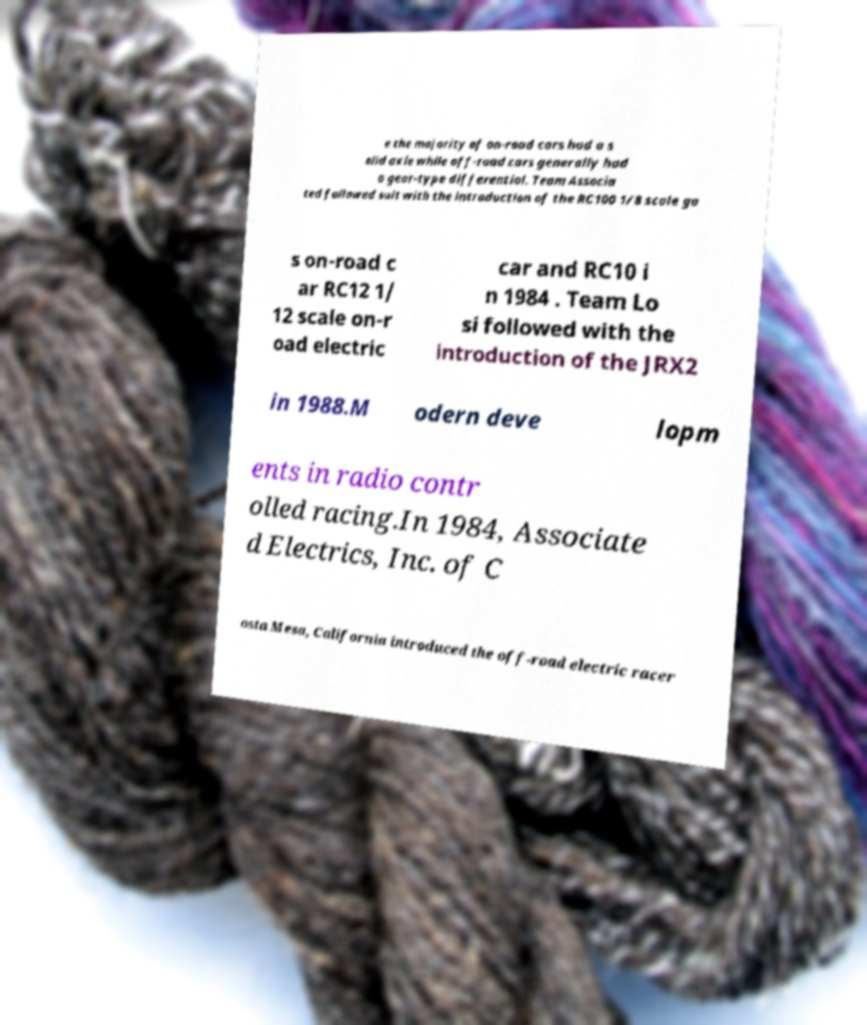For documentation purposes, I need the text within this image transcribed. Could you provide that? e the majority of on-road cars had a s olid axle while off-road cars generally had a gear-type differential. Team Associa ted followed suit with the introduction of the RC100 1/8 scale ga s on-road c ar RC12 1/ 12 scale on-r oad electric car and RC10 i n 1984 . Team Lo si followed with the introduction of the JRX2 in 1988.M odern deve lopm ents in radio contr olled racing.In 1984, Associate d Electrics, Inc. of C osta Mesa, California introduced the off-road electric racer 